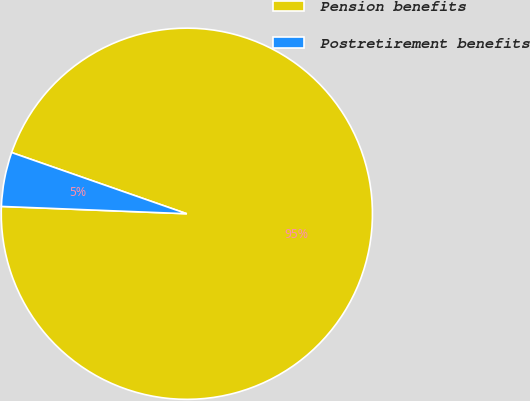<chart> <loc_0><loc_0><loc_500><loc_500><pie_chart><fcel>Pension benefits<fcel>Postretirement benefits<nl><fcel>95.28%<fcel>4.72%<nl></chart> 